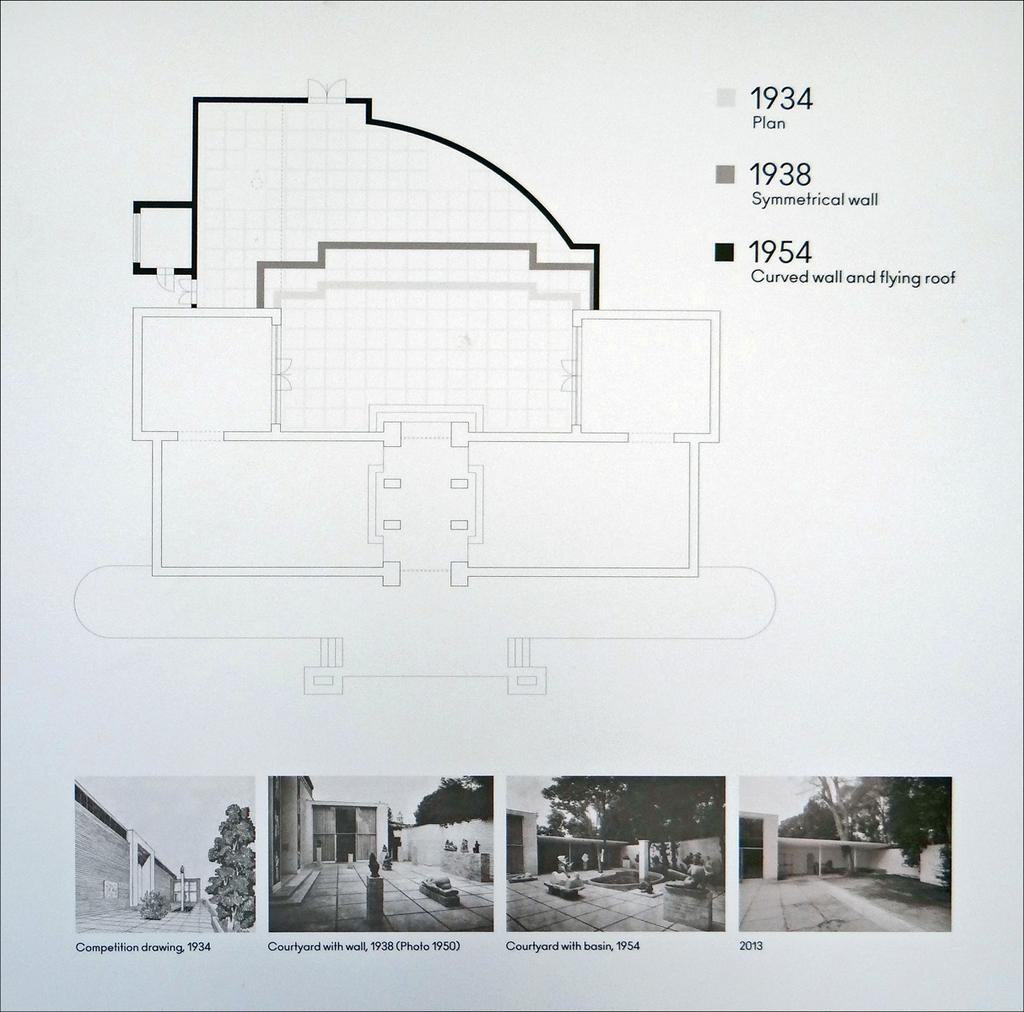What type of structures can be seen in the image? There are buildings in the image in the image. What natural elements are present in the image? There are trees in the image. Are there any artistic features in the image? Yes, there are statues in the image. What is visible in the sky in the image? The sky is visible in the image. What type of illustration can be seen in the image? There is a diagram in the image. What is written on the diagram? Something is written on the diagram. What is the background color of the image? The background color is white. Can you tell me how many insects are crawling on the diagram in the image? There are no insects present in the image, and therefore no such activity can be observed. What type of detail can be seen on the turkey in the image? There is no turkey present in the image. 